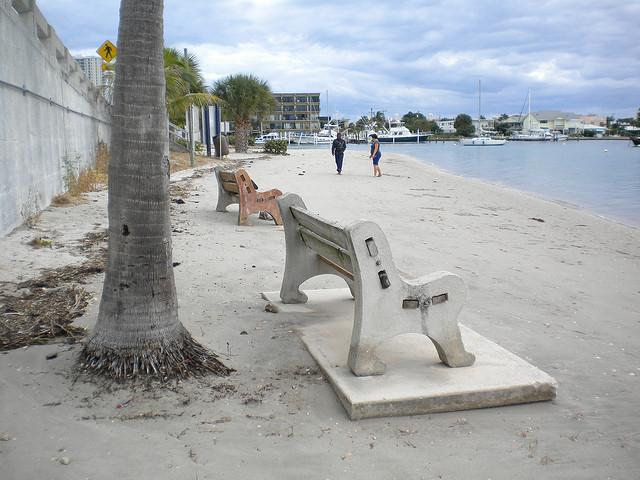What are the benches for?

Choices:
A) washed ashore
B) resting
C) for sale
D) surfing resting 